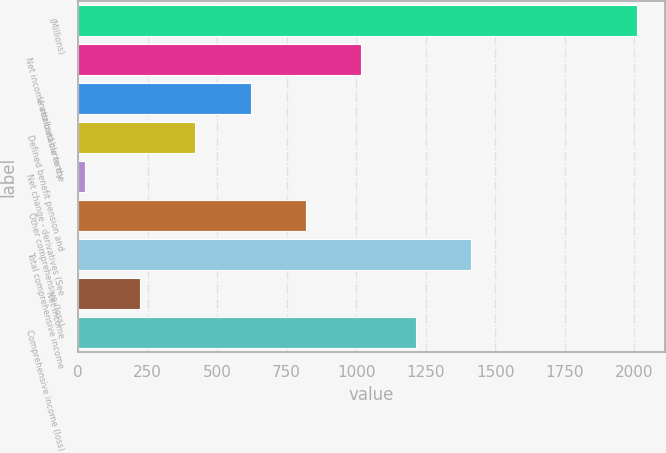Convert chart. <chart><loc_0><loc_0><loc_500><loc_500><bar_chart><fcel>(Millions)<fcel>Net income attributable to the<fcel>Unrealized currency<fcel>Defined benefit pension and<fcel>Net change - derivatives (See<fcel>Other comprehensive (loss)<fcel>Total comprehensive income<fcel>Net income<fcel>Comprehensive income (loss)<nl><fcel>2009<fcel>1017<fcel>620.2<fcel>421.8<fcel>25<fcel>818.6<fcel>1413.8<fcel>223.4<fcel>1215.4<nl></chart> 